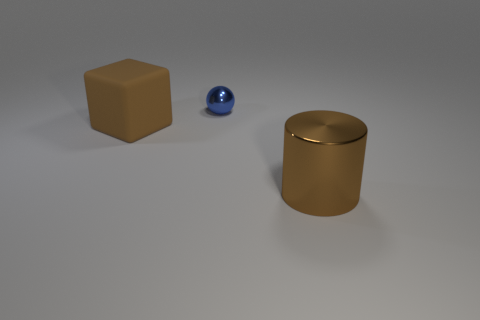Do the large metallic cylinder and the thing left of the sphere have the same color?
Your response must be concise. Yes. There is a large thing behind the brown thing that is to the right of the matte block behind the cylinder; what is its color?
Keep it short and to the point. Brown. Is there a large brown matte thing of the same shape as the blue metal thing?
Ensure brevity in your answer.  No. The matte cube that is the same size as the brown metal thing is what color?
Ensure brevity in your answer.  Brown. What is the big thing that is to the right of the large rubber cube made of?
Give a very brief answer. Metal. Is the number of big metal cylinders that are in front of the tiny blue sphere the same as the number of large things?
Your answer should be very brief. No. What number of other green things have the same material as the small object?
Keep it short and to the point. 0. What is the color of the cylinder that is the same material as the tiny blue thing?
Provide a succinct answer. Brown. There is a shiny ball; is it the same size as the object that is in front of the matte thing?
Provide a succinct answer. No. What is the shape of the large metallic object?
Ensure brevity in your answer.  Cylinder. 